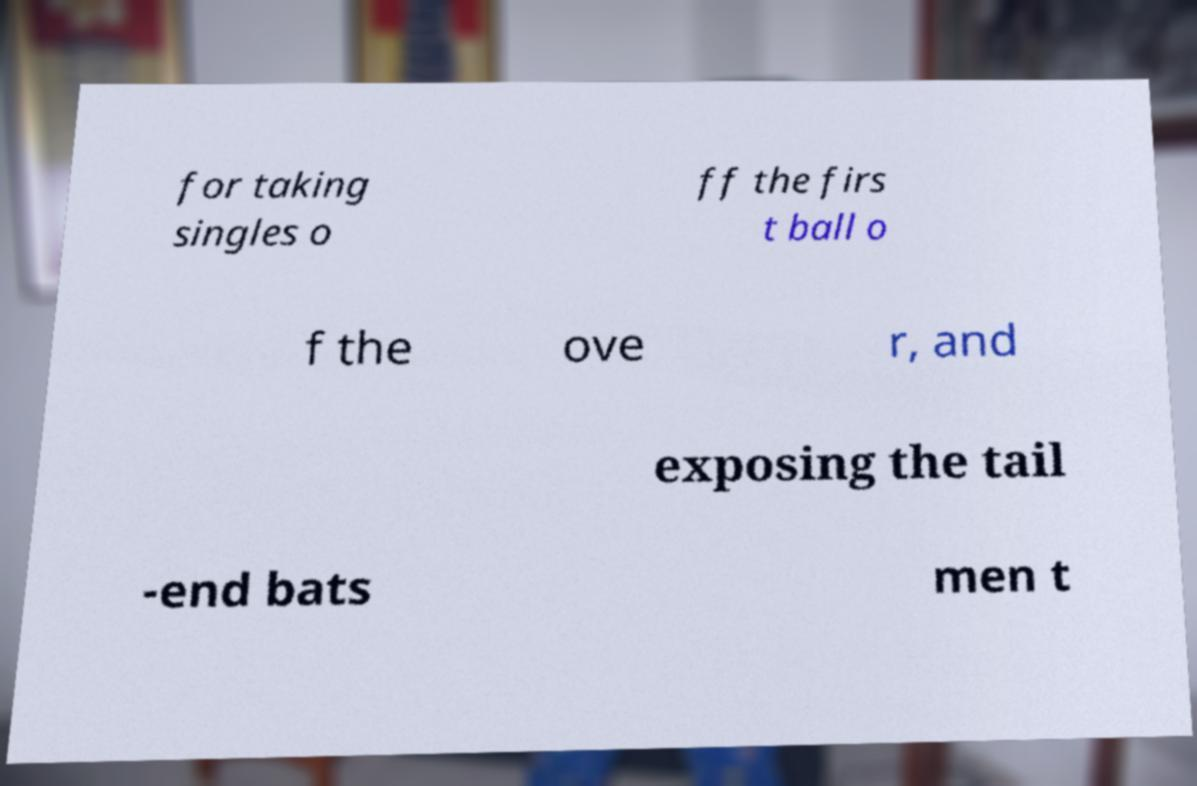There's text embedded in this image that I need extracted. Can you transcribe it verbatim? for taking singles o ff the firs t ball o f the ove r, and exposing the tail -end bats men t 